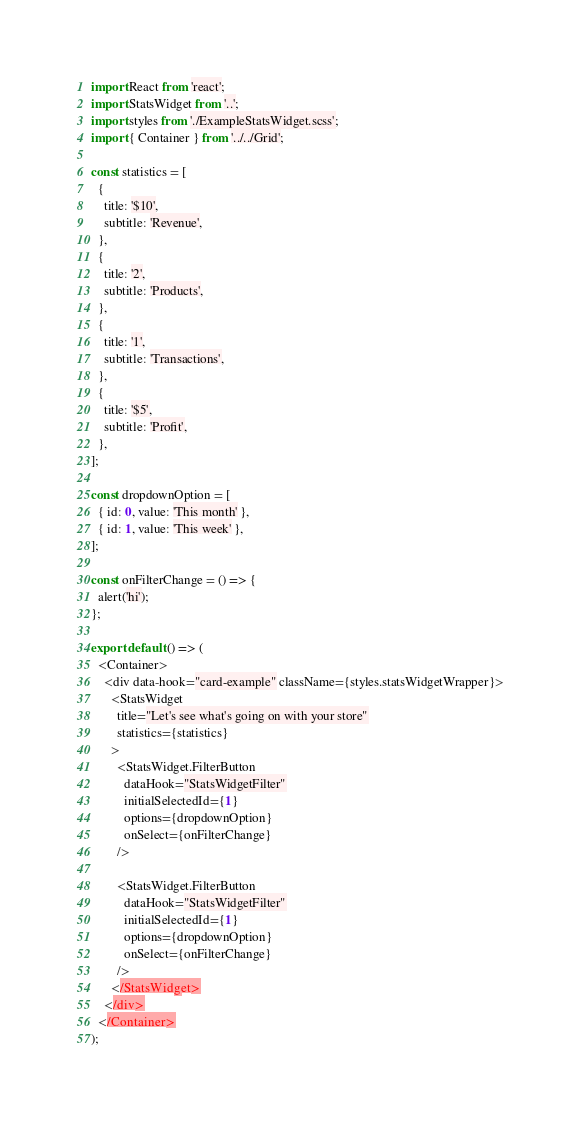<code> <loc_0><loc_0><loc_500><loc_500><_JavaScript_>import React from 'react';
import StatsWidget from '..';
import styles from './ExampleStatsWidget.scss';
import { Container } from '../../Grid';

const statistics = [
  {
    title: '$10',
    subtitle: 'Revenue',
  },
  {
    title: '2',
    subtitle: 'Products',
  },
  {
    title: '1',
    subtitle: 'Transactions',
  },
  {
    title: '$5',
    subtitle: 'Profit',
  },
];

const dropdownOption = [
  { id: 0, value: 'This month' },
  { id: 1, value: 'This week' },
];

const onFilterChange = () => {
  alert('hi');
};

export default () => (
  <Container>
    <div data-hook="card-example" className={styles.statsWidgetWrapper}>
      <StatsWidget
        title="Let's see what's going on with your store"
        statistics={statistics}
      >
        <StatsWidget.FilterButton
          dataHook="StatsWidgetFilter"
          initialSelectedId={1}
          options={dropdownOption}
          onSelect={onFilterChange}
        />

        <StatsWidget.FilterButton
          dataHook="StatsWidgetFilter"
          initialSelectedId={1}
          options={dropdownOption}
          onSelect={onFilterChange}
        />
      </StatsWidget>
    </div>
  </Container>
);
</code> 